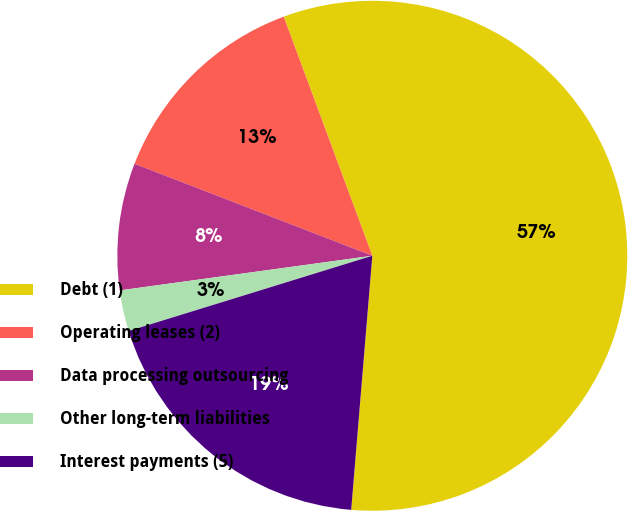Convert chart. <chart><loc_0><loc_0><loc_500><loc_500><pie_chart><fcel>Debt (1)<fcel>Operating leases (2)<fcel>Data processing outsourcing<fcel>Other long-term liabilities<fcel>Interest payments (5)<nl><fcel>56.97%<fcel>13.48%<fcel>8.04%<fcel>2.6%<fcel>18.91%<nl></chart> 